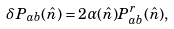<formula> <loc_0><loc_0><loc_500><loc_500>\delta P _ { a b } ( \hat { n } ) = 2 \alpha ( \hat { n } ) P _ { a b } ^ { r } ( \hat { n } ) ,</formula> 